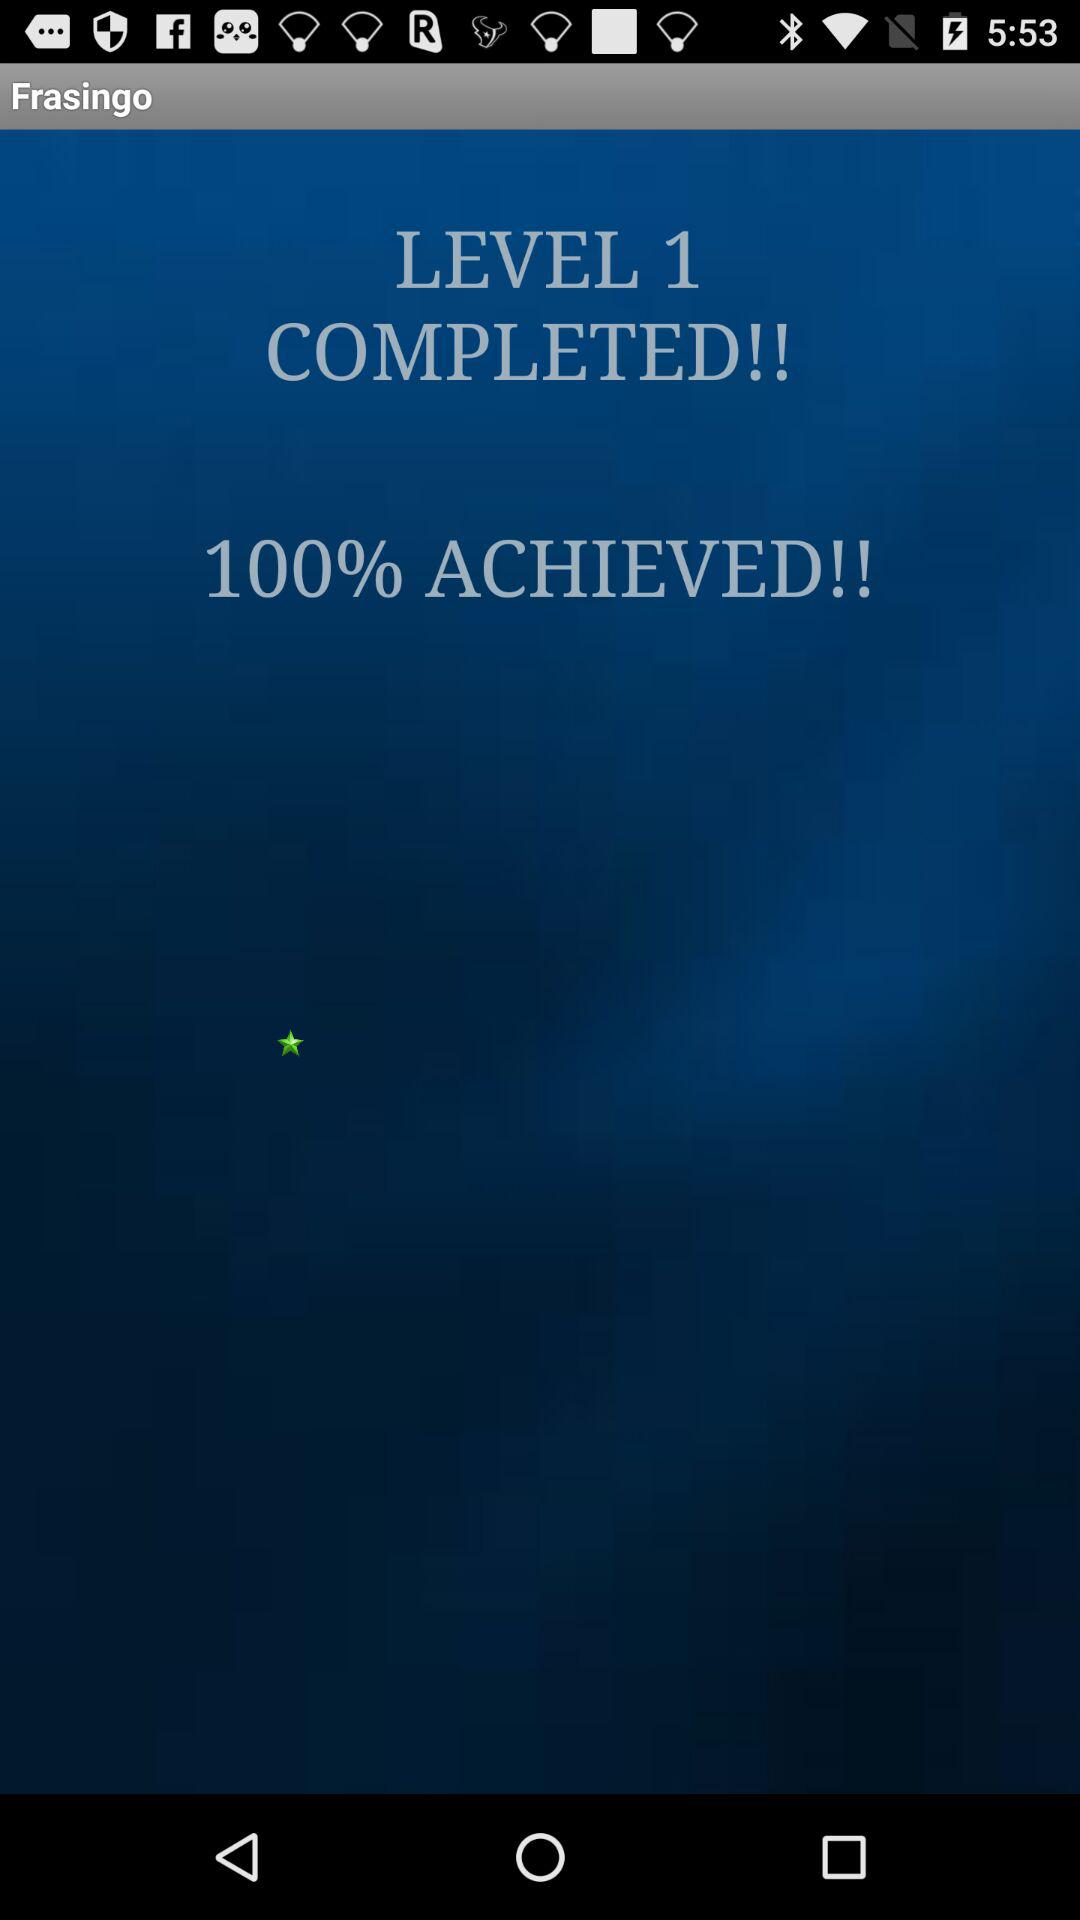How many percent is completed?
Answer the question using a single word or phrase. 100% 